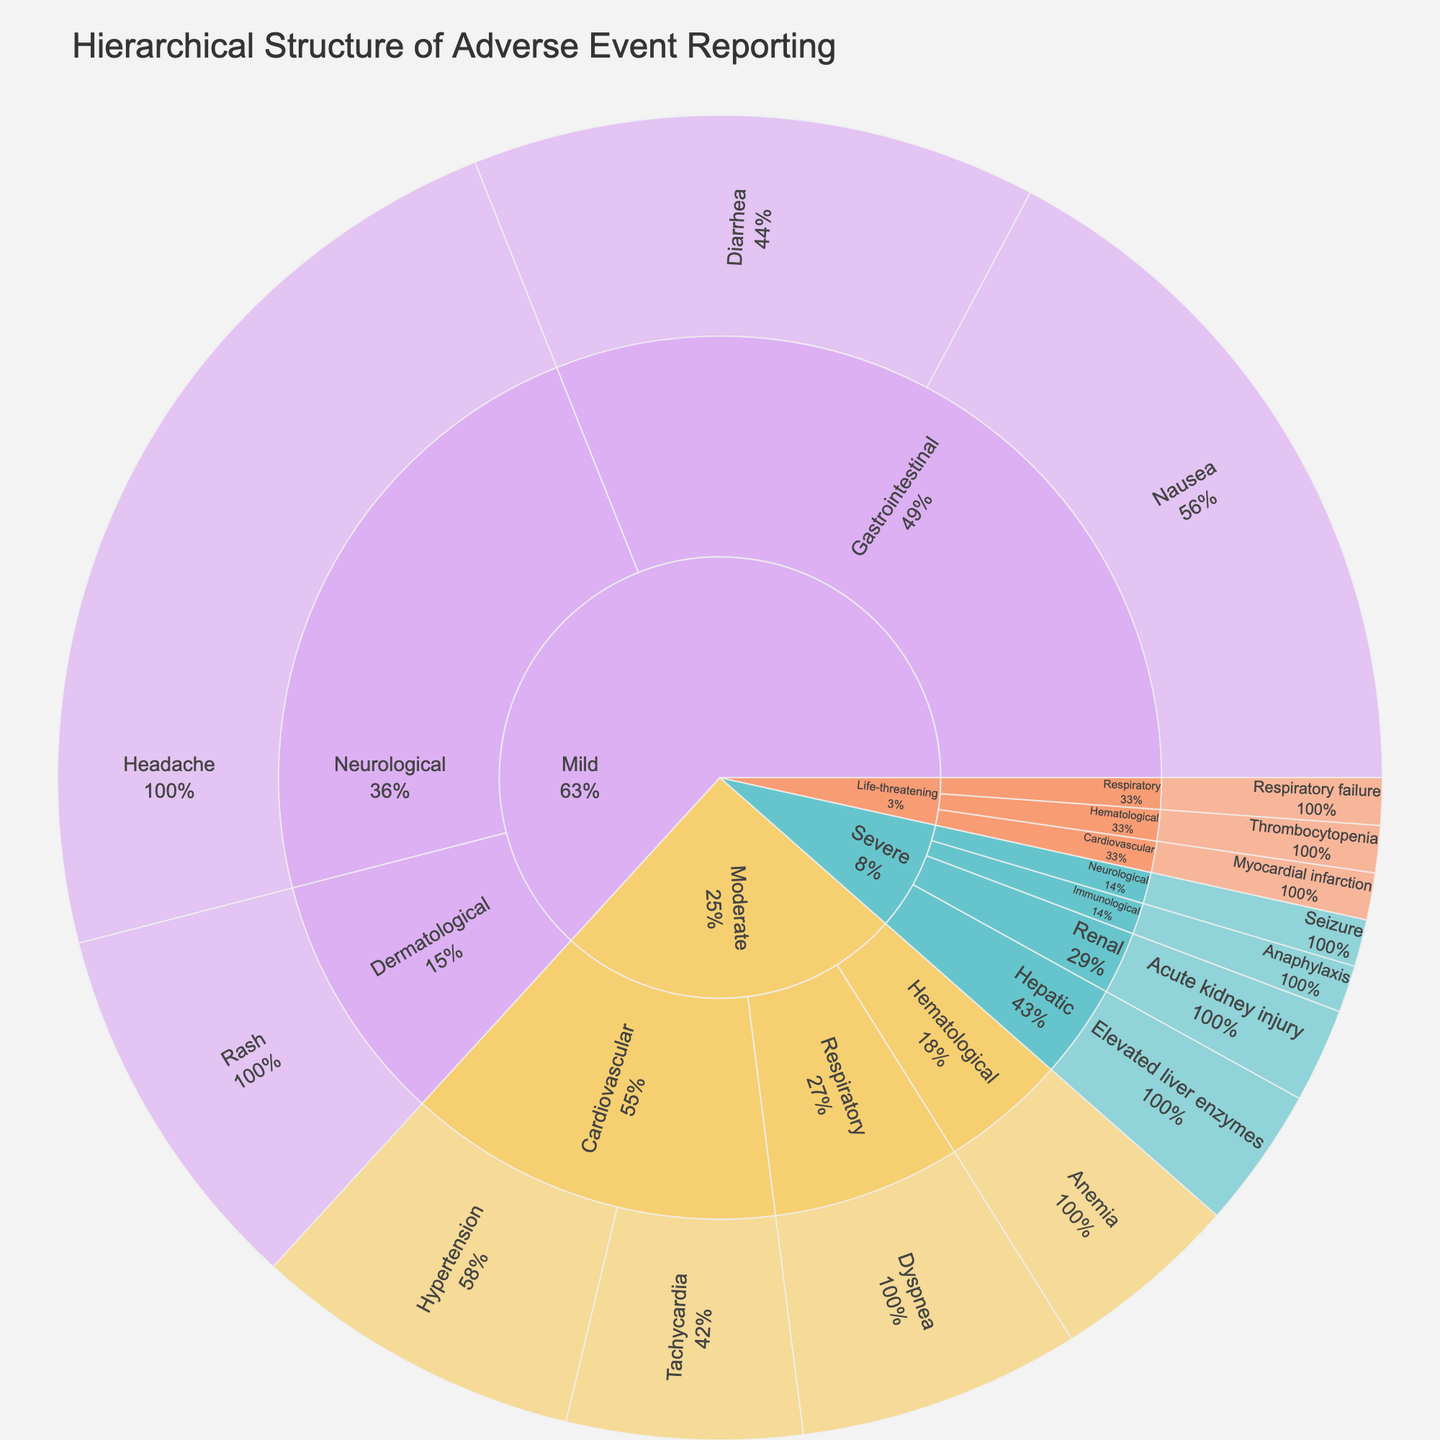What's the title of the figure? The title is usually positioned at the top of the plot. In this case, it is clearly indicated at the top of the sunburst plot.
Answer: Hierarchical Structure of Adverse Event Reporting How many categories of severity are presented in the plot? The outermost ring of the sunburst plot shows the different categories of severity split into distinct sections with different colors. By counting these sections, you can determine the number of categories.
Answer: 4 Which specific symptom has the highest count? Within the sunburst plot, the size of each segment is proportional to its value. Identifying the largest segment within the "subsubcategory" level will give you the symptom with the highest count.
Answer: Headache What's the total count of adverse events reported for severe severity? To find this, you sum up the counts of all subcategories under 'Severe' severity. The values for severe severity are 3 (Hepatic), 2 (Renal), 1 (Immunological), and 1 (Neurological). Adding these gives the total count.
Answer: 7 Which organ system has the highest count of moderate adverse events? By looking at the 'Moderate' category in the sunburst plot and comparing the size of each subsector within, you can identify the largest organ system under the moderate severity.
Answer: Cardiovascular What is the ratio of the number of mild neurological adverse events to mild gastrointestinal adverse events? Sum the values for mild neurological events (Headache: 20) and compare it with the sum of mild gastrointestinal events (Nausea: 15, Diarrhea: 12). Calculate the ratio as 20 / (15 + 12).
Answer: 20:27 How does the count of life-threatening cardiovascular adverse events compare to life-threatening respiratory adverse events? Look at the specific segments for life-threatening cardiovascular (Myocardial infarction: 1) and for respiratory (Respiratory failure: 1) in the sunburst plot and compare the counts directly.
Answer: Equal Which severity category has the least number of adverse events, and how many are reported in total for that category? By examining the plot, you can compare the total size of each severity category. The category with the smallest total sum of values is 'Life-threatening.' Each subcategory within 'Life-threatening' has a count of 1. Adding these gives the total count.
Answer: Life-threatening, 3 What percentage of mild adverse events involved gastrointestinal issues? Sum the values for mild adverse events (Headache: 20, Nausea: 15, Diarrhea: 12, Rash: 8). Then sum the values for the mild gastrointestinal issues (Nausea: 15, Diarrhea: 12). Divide the gastrointestinal total by the overall mild total and multiply by 100 to get the percentage.
Answer: 27/55 ≈ 49.1% How many more mild dermatological adverse events are there compared to severe renal adverse events? Identify the counts for mild dermatological (Rash: 8) and severe renal (Acute kidney injury: 2). Subtract the latter from the former to get the difference.
Answer: 6 